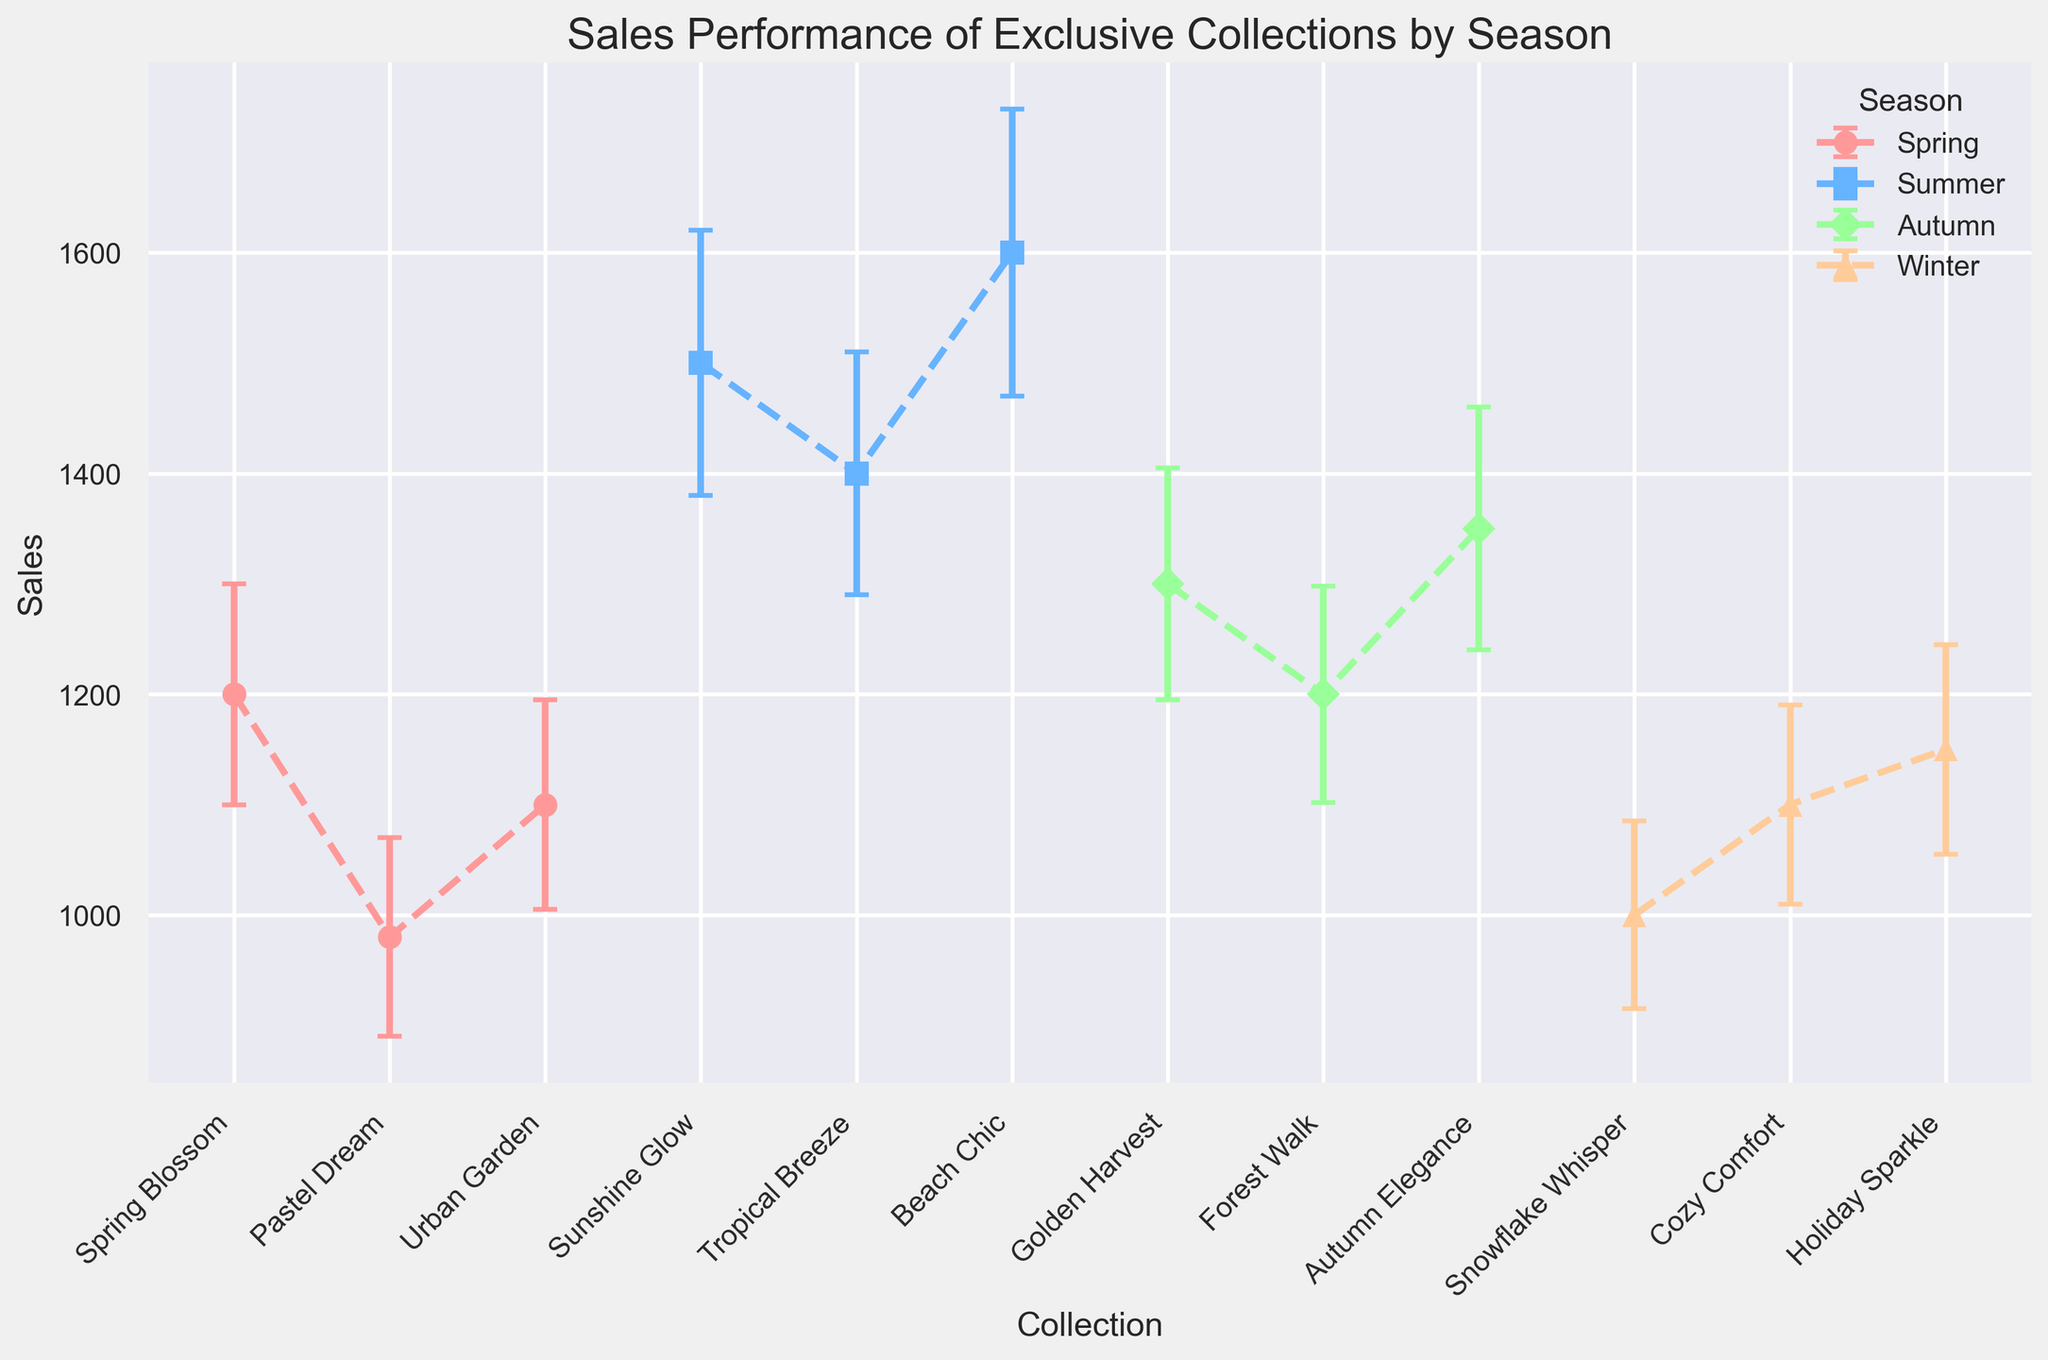Which season has the highest sales collection on average? Calculate the average sales for each season. The averages are: Spring (1080), Summer (1500), Autumn (1283.33), Winter (1050). Summer has the highest average sales.
Answer: Summer Which collection has the greatest variability in sales? Identify the collection with the highest standard deviation. The collections and their standard deviations are: Spring Blossom (100), Pastel Dream (90), Urban Garden (95), Sunshine Glow (120), Tropical Breeze (110), Beach Chic (130), Golden Harvest (105), Forest Walk (98), Autumn Elegance (110), Snowflake Whisper (85), Cozy Comfort (90), Holiday Sparkle (95). Beach Chic has the highest standard deviation.
Answer: Beach Chic How does the sales performance of 'Urban Garden' compare to 'Forest Walk'? Compare the sales of 'Urban Garden' which is 1100 with 'Forest Walk' which is 1200. 'Forest Walk' has higher sales.
Answer: Forest Walk has higher sales What is the difference in sales between the best-performing collection in Summer and the best-performing collection in Winter? The best-performing collection in Summer is 'Beach Chic' with 1600 sales and in Winter is 'Holiday Sparkle' with 1150 sales. The difference is 1600 - 1150 = 450.
Answer: 450 Which season has the least variations in sales among its collections? Calculate the average standard deviation for each season. Spring (95), Summer (120), Autumn (104.33), Winter (90). Winter has the least variability.
Answer: Winter Which collection in 'Autumn' has the highest sales, and what are those sales? Among 'Golden Harvest', 'Forest Walk', and 'Autumn Elegance', 'Autumn Elegance' has the highest sales at 1350.
Answer: Autumn Elegance with 1350 What is the average sales performance of collections in Spring? Sum the sales of collections in Spring: 1200 + 980 + 1100 = 3280. Divide by 3 for the average: 3280 / 3 ≈ 1093.33.
Answer: 1093.33 Among 'Cozy Comfort' and 'Holiday Sparkle', which has a smaller variability in sales and what is the standard deviation? 'Cozy Comfort' has a standard deviation of 90, while 'Holiday Sparkle' has 95. So, 'Cozy Comfort' has a smaller variability.
Answer: Cozy Comfort with 90 What is the combined standard deviation of 'Sunshine Glow' and 'Tropical Breeze'? The combined standard deviation is calculated by taking the square root of the sum of the squares of individual standard deviations: sqrt(120^2 + 110^2) ≈ sqrt(14400 + 12100) = sqrt(26500) ≈ 162.8.
Answer: ≈ 162.8 Which two collections in the same season have the closest sales figures? Find the sales differences for collections within each season. The smallest difference is between 'Golden Harvest' (1300) and 'Autumn Elegance' (1350) in Autumn, with a difference of 50.
Answer: Golden Harvest and Autumn Elegance with a difference of 50 